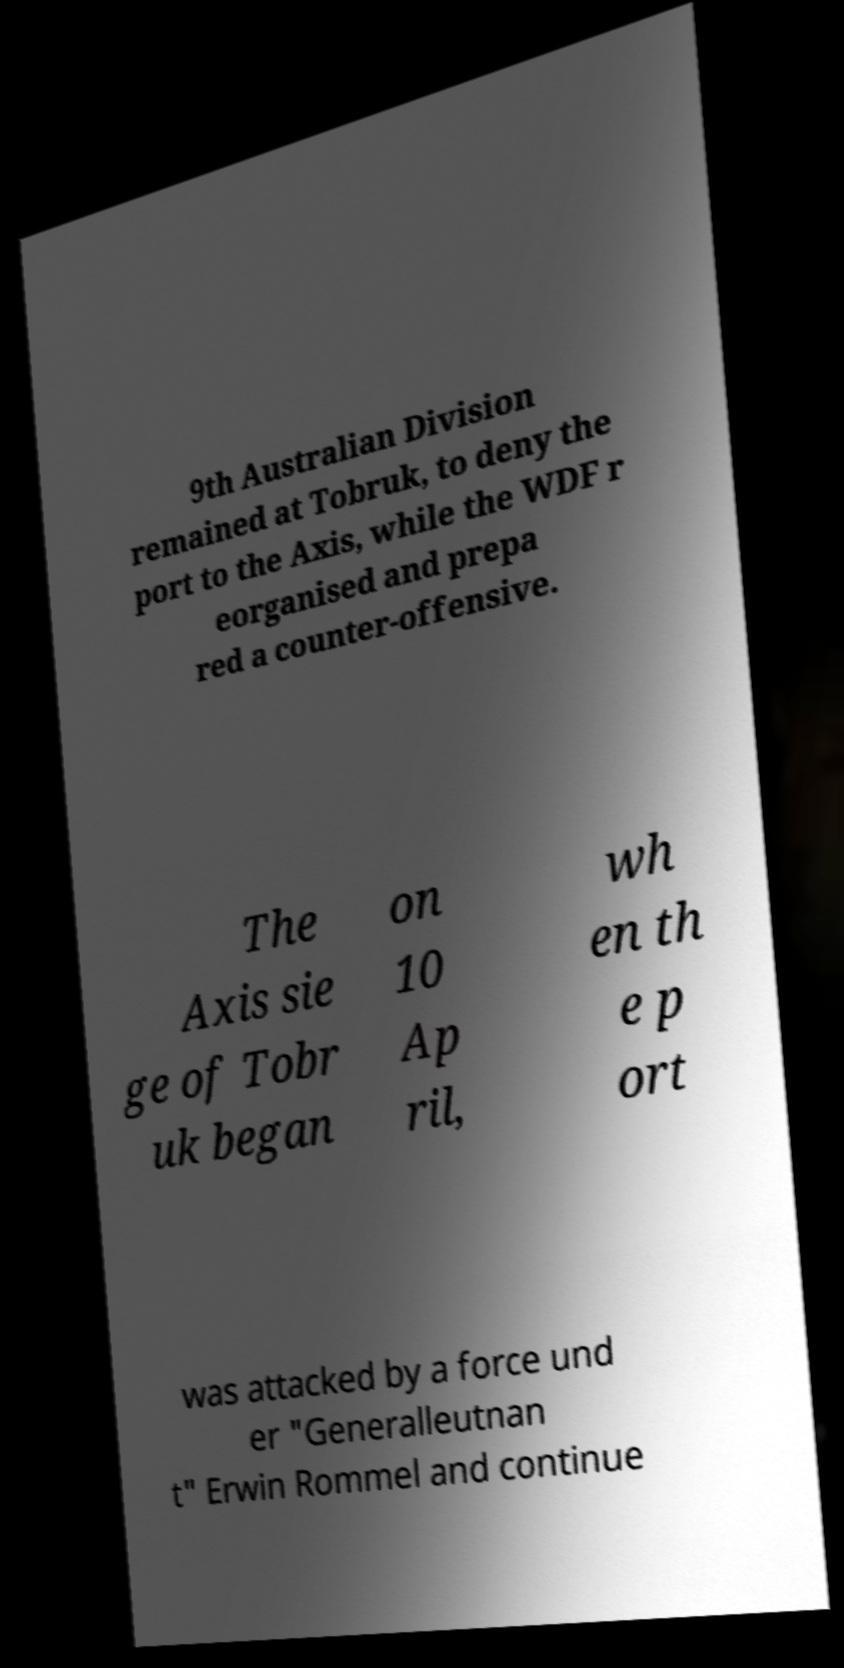Please identify and transcribe the text found in this image. 9th Australian Division remained at Tobruk, to deny the port to the Axis, while the WDF r eorganised and prepa red a counter-offensive. The Axis sie ge of Tobr uk began on 10 Ap ril, wh en th e p ort was attacked by a force und er "Generalleutnan t" Erwin Rommel and continue 